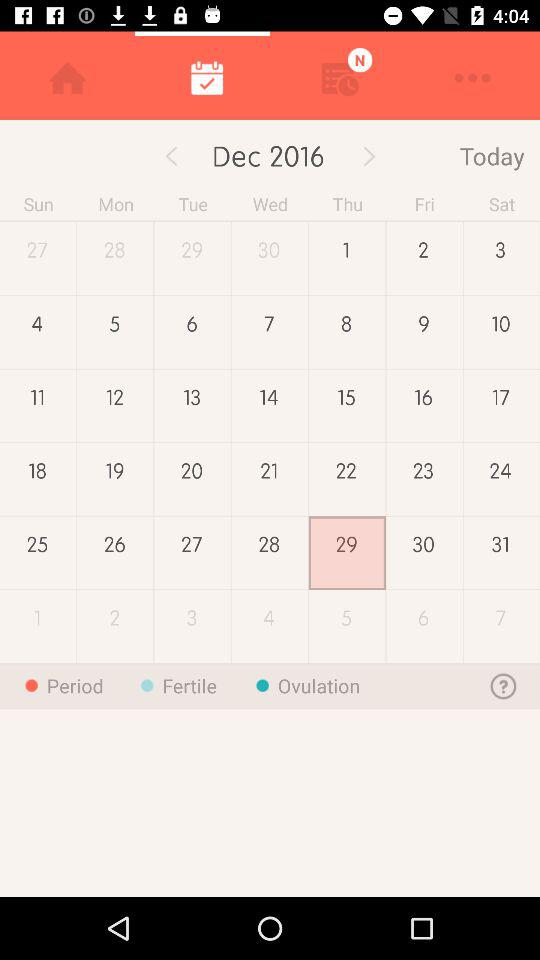What date is selected? The selected date is Thursday, December 29, 2016. 